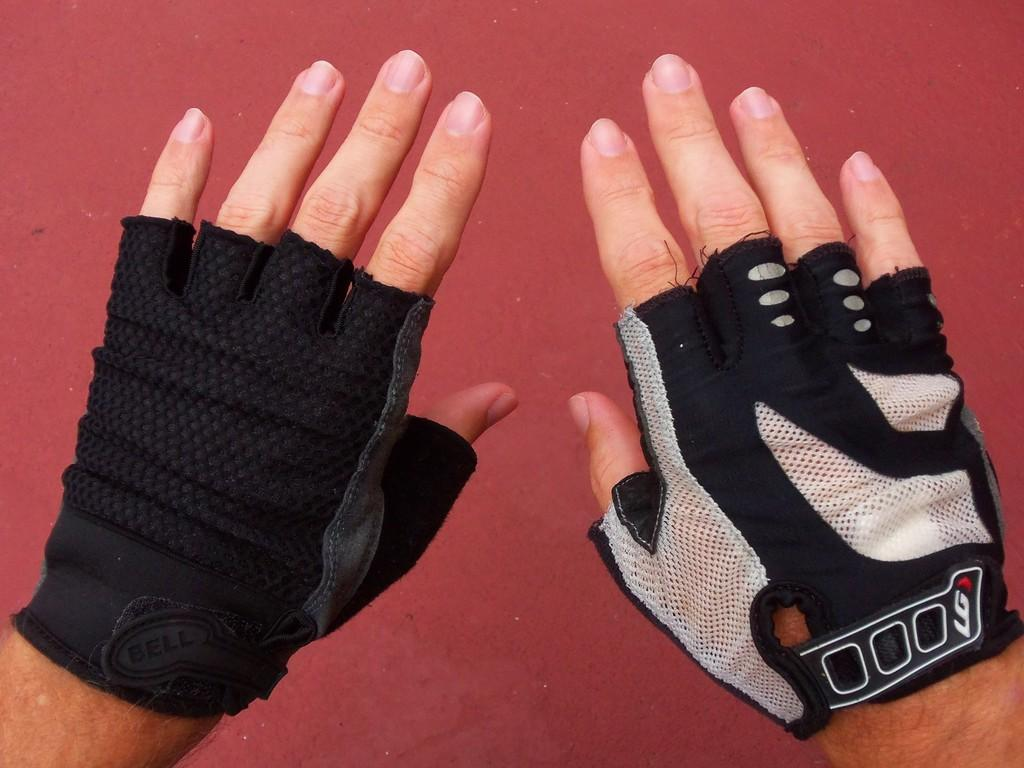What objects are on human hands in the image? There are gloves on human hands in the image. What color is the background of the image? The background color is maroon. What type of observation can be made about the circle in the image? There is no circle present in the image. What is the needle used for in the image? There is no needle present in the image. 